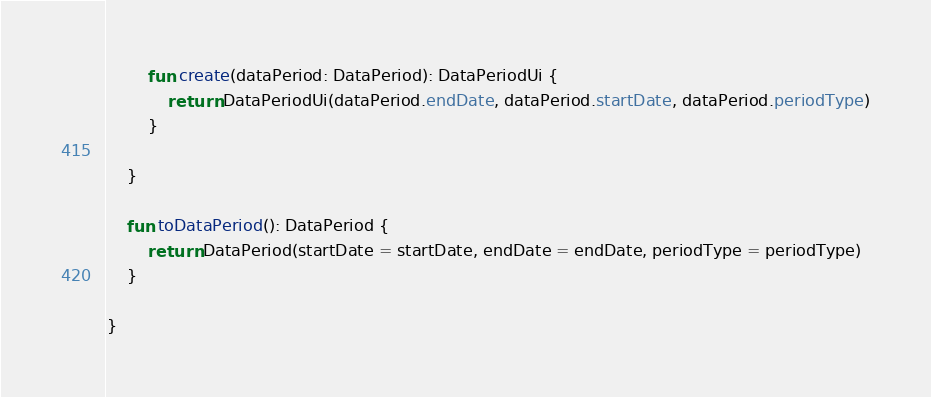<code> <loc_0><loc_0><loc_500><loc_500><_Kotlin_>        fun create(dataPeriod: DataPeriod): DataPeriodUi {
            return DataPeriodUi(dataPeriod.endDate, dataPeriod.startDate, dataPeriod.periodType)
        }

    }

    fun toDataPeriod(): DataPeriod {
        return DataPeriod(startDate = startDate, endDate = endDate, periodType = periodType)
    }

}</code> 